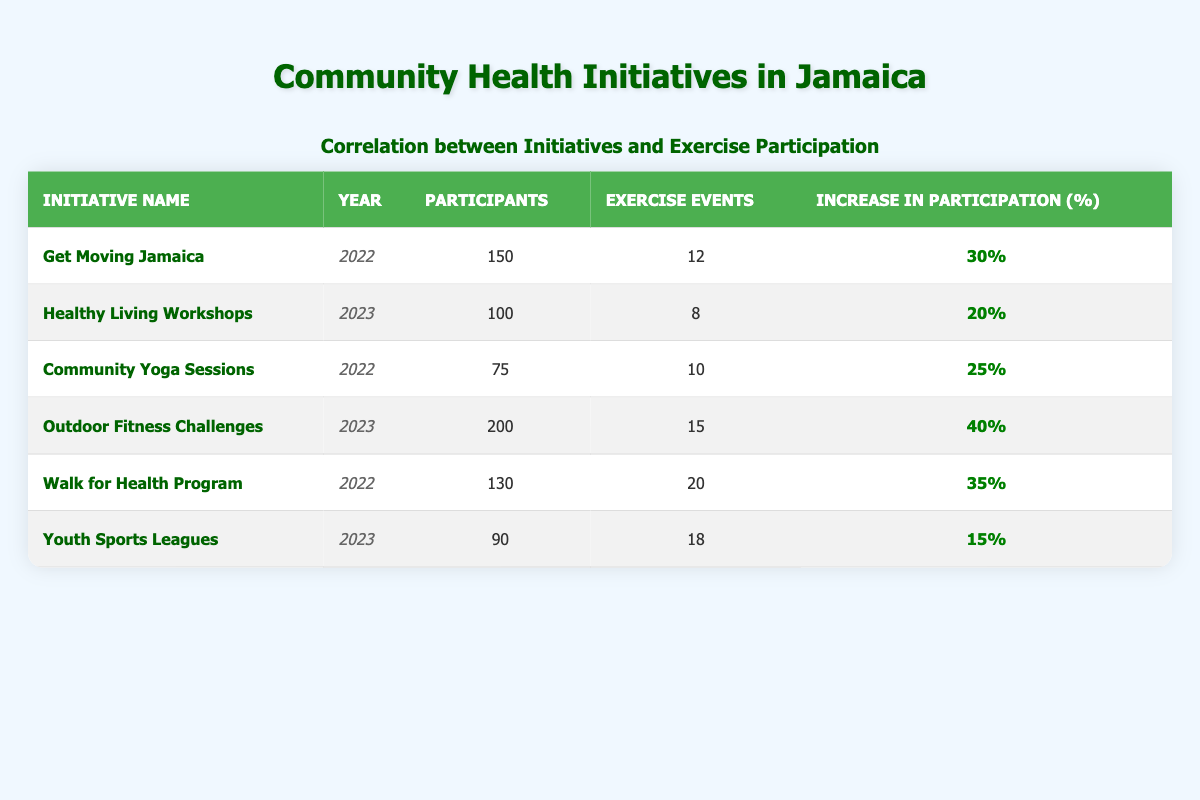What is the initiative with the highest number of participants? By examining the "participants" column, we can see that the "Outdoor Fitness Challenges" initiative has the highest number of participants at 200.
Answer: Outdoor Fitness Challenges Which initiative had the lowest increase in participation percentage? When reviewing the "increase in participation (%)" column, the "Youth Sports Leagues" had the lowest increase at 15%.
Answer: Youth Sports Leagues What is the total number of exercise events across all initiatives? To find the total number of exercise events, we sum the values in the "exercise events" column: 12 + 8 + 10 + 15 + 20 + 18 = 83.
Answer: 83 Which initiatives took place in 2022 and achieved an increase in participation over 30%? Looking at the year and increase in participation columns, the initiatives in 2022 that had an increase over 30% are "Get Moving Jamaica" (30%) and "Walk for Health Program" (35%). However, only "Walk for Health Program" exceeds 30%.
Answer: Walk for Health Program Is it true that all initiatives in 2023 had more events than those in 2022? Checking the "exercise events" for 2023: Healthy Living Workshops (8), Outdoor Fitness Challenges (15), and Youth Sports Leagues (18), we see that not all have more events than those in 2022, as Community Yoga Sessions (10) exceeds Healthy Living Workshops (8). Therefore, the answer is false.
Answer: False What is the average increase in participation for all initiatives in 2022? The increase percentages for 2022 are 30% (Get Moving Jamaica), 25% (Community Yoga Sessions), and 35% (Walk for Health Program). The total is 30 + 25 + 35 = 90%. There are three initiatives, so the average is 90/3 = 30%.
Answer: 30% Which initiative in 2023 had the most exercise events? By reviewing the "exercise events" column for 2023, we see "Outdoor Fitness Challenges" with 15 events has more compared to "Healthy Living Workshops" (8) and "Youth Sports Leagues" (18). Therefore, the one with the most events is "Youth Sports Leagues" with 18.
Answer: Youth Sports Leagues What is the combined total of participants in initiatives from 2022? From the "participants" column, adding the numbers from 2022: 150 (Get Moving Jamaica) + 75 (Community Yoga Sessions) + 130 (Walk for Health Program) = 355 participants in total.
Answer: 355 Which initiative had a significant impact, with an increase in participation by 40%? The initiative with the highest increase in participation is "Outdoor Fitness Challenges," which had a 40% increase.
Answer: Outdoor Fitness Challenges 